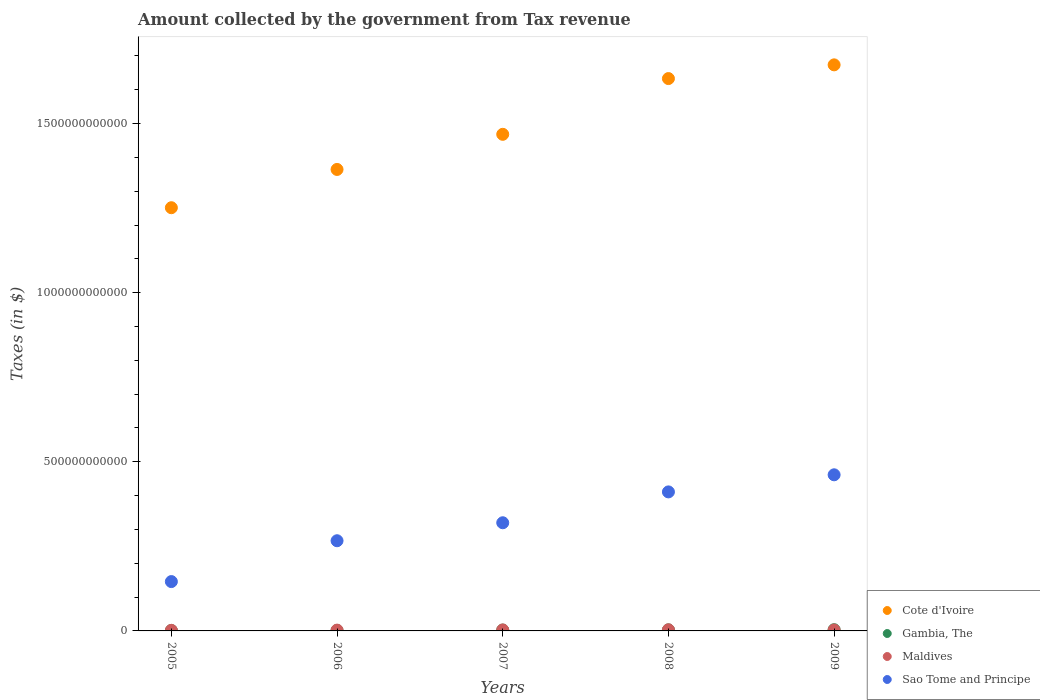What is the amount collected by the government from tax revenue in Gambia, The in 2009?
Keep it short and to the point. 3.63e+09. Across all years, what is the maximum amount collected by the government from tax revenue in Sao Tome and Principe?
Offer a very short reply. 4.62e+11. Across all years, what is the minimum amount collected by the government from tax revenue in Sao Tome and Principe?
Ensure brevity in your answer.  1.46e+11. In which year was the amount collected by the government from tax revenue in Maldives maximum?
Make the answer very short. 2008. In which year was the amount collected by the government from tax revenue in Sao Tome and Principe minimum?
Keep it short and to the point. 2005. What is the total amount collected by the government from tax revenue in Gambia, The in the graph?
Provide a succinct answer. 1.21e+1. What is the difference between the amount collected by the government from tax revenue in Cote d'Ivoire in 2005 and that in 2006?
Your response must be concise. -1.13e+11. What is the difference between the amount collected by the government from tax revenue in Maldives in 2006 and the amount collected by the government from tax revenue in Gambia, The in 2007?
Your response must be concise. -2.19e+08. What is the average amount collected by the government from tax revenue in Gambia, The per year?
Provide a succinct answer. 2.42e+09. In the year 2008, what is the difference between the amount collected by the government from tax revenue in Gambia, The and amount collected by the government from tax revenue in Sao Tome and Principe?
Ensure brevity in your answer.  -4.08e+11. What is the ratio of the amount collected by the government from tax revenue in Maldives in 2006 to that in 2009?
Offer a very short reply. 0.87. What is the difference between the highest and the second highest amount collected by the government from tax revenue in Cote d'Ivoire?
Ensure brevity in your answer.  4.06e+1. What is the difference between the highest and the lowest amount collected by the government from tax revenue in Gambia, The?
Give a very brief answer. 2.34e+09. Is the amount collected by the government from tax revenue in Sao Tome and Principe strictly greater than the amount collected by the government from tax revenue in Cote d'Ivoire over the years?
Your answer should be very brief. No. Is the amount collected by the government from tax revenue in Cote d'Ivoire strictly less than the amount collected by the government from tax revenue in Maldives over the years?
Your response must be concise. No. What is the difference between two consecutive major ticks on the Y-axis?
Keep it short and to the point. 5.00e+11. Does the graph contain any zero values?
Make the answer very short. No. Does the graph contain grids?
Your answer should be very brief. No. Where does the legend appear in the graph?
Ensure brevity in your answer.  Bottom right. How many legend labels are there?
Make the answer very short. 4. What is the title of the graph?
Make the answer very short. Amount collected by the government from Tax revenue. Does "Latvia" appear as one of the legend labels in the graph?
Provide a short and direct response. No. What is the label or title of the Y-axis?
Your answer should be very brief. Taxes (in $). What is the Taxes (in $) of Cote d'Ivoire in 2005?
Make the answer very short. 1.25e+12. What is the Taxes (in $) of Gambia, The in 2005?
Provide a short and direct response. 1.29e+09. What is the Taxes (in $) of Maldives in 2005?
Your answer should be very brief. 1.72e+09. What is the Taxes (in $) of Sao Tome and Principe in 2005?
Keep it short and to the point. 1.46e+11. What is the Taxes (in $) of Cote d'Ivoire in 2006?
Your response must be concise. 1.36e+12. What is the Taxes (in $) in Gambia, The in 2006?
Provide a succinct answer. 1.47e+09. What is the Taxes (in $) of Maldives in 2006?
Provide a succinct answer. 2.37e+09. What is the Taxes (in $) in Sao Tome and Principe in 2006?
Your answer should be very brief. 2.67e+11. What is the Taxes (in $) of Cote d'Ivoire in 2007?
Offer a terse response. 1.47e+12. What is the Taxes (in $) of Gambia, The in 2007?
Offer a terse response. 2.59e+09. What is the Taxes (in $) of Maldives in 2007?
Make the answer very short. 2.91e+09. What is the Taxes (in $) in Sao Tome and Principe in 2007?
Ensure brevity in your answer.  3.20e+11. What is the Taxes (in $) in Cote d'Ivoire in 2008?
Your answer should be compact. 1.63e+12. What is the Taxes (in $) of Gambia, The in 2008?
Your answer should be compact. 3.15e+09. What is the Taxes (in $) in Maldives in 2008?
Offer a terse response. 3.37e+09. What is the Taxes (in $) in Sao Tome and Principe in 2008?
Ensure brevity in your answer.  4.11e+11. What is the Taxes (in $) of Cote d'Ivoire in 2009?
Offer a very short reply. 1.67e+12. What is the Taxes (in $) of Gambia, The in 2009?
Make the answer very short. 3.63e+09. What is the Taxes (in $) of Maldives in 2009?
Provide a succinct answer. 2.73e+09. What is the Taxes (in $) of Sao Tome and Principe in 2009?
Make the answer very short. 4.62e+11. Across all years, what is the maximum Taxes (in $) in Cote d'Ivoire?
Your answer should be compact. 1.67e+12. Across all years, what is the maximum Taxes (in $) of Gambia, The?
Your answer should be very brief. 3.63e+09. Across all years, what is the maximum Taxes (in $) in Maldives?
Offer a very short reply. 3.37e+09. Across all years, what is the maximum Taxes (in $) in Sao Tome and Principe?
Make the answer very short. 4.62e+11. Across all years, what is the minimum Taxes (in $) in Cote d'Ivoire?
Your response must be concise. 1.25e+12. Across all years, what is the minimum Taxes (in $) of Gambia, The?
Provide a short and direct response. 1.29e+09. Across all years, what is the minimum Taxes (in $) in Maldives?
Give a very brief answer. 1.72e+09. Across all years, what is the minimum Taxes (in $) of Sao Tome and Principe?
Offer a terse response. 1.46e+11. What is the total Taxes (in $) in Cote d'Ivoire in the graph?
Your answer should be compact. 7.39e+12. What is the total Taxes (in $) of Gambia, The in the graph?
Give a very brief answer. 1.21e+1. What is the total Taxes (in $) in Maldives in the graph?
Offer a terse response. 1.31e+1. What is the total Taxes (in $) in Sao Tome and Principe in the graph?
Keep it short and to the point. 1.60e+12. What is the difference between the Taxes (in $) in Cote d'Ivoire in 2005 and that in 2006?
Make the answer very short. -1.13e+11. What is the difference between the Taxes (in $) in Gambia, The in 2005 and that in 2006?
Ensure brevity in your answer.  -1.80e+08. What is the difference between the Taxes (in $) of Maldives in 2005 and that in 2006?
Offer a terse response. -6.48e+08. What is the difference between the Taxes (in $) of Sao Tome and Principe in 2005 and that in 2006?
Offer a very short reply. -1.21e+11. What is the difference between the Taxes (in $) of Cote d'Ivoire in 2005 and that in 2007?
Offer a terse response. -2.17e+11. What is the difference between the Taxes (in $) in Gambia, The in 2005 and that in 2007?
Your response must be concise. -1.30e+09. What is the difference between the Taxes (in $) of Maldives in 2005 and that in 2007?
Offer a very short reply. -1.18e+09. What is the difference between the Taxes (in $) in Sao Tome and Principe in 2005 and that in 2007?
Your answer should be compact. -1.74e+11. What is the difference between the Taxes (in $) of Cote d'Ivoire in 2005 and that in 2008?
Provide a succinct answer. -3.82e+11. What is the difference between the Taxes (in $) in Gambia, The in 2005 and that in 2008?
Offer a very short reply. -1.86e+09. What is the difference between the Taxes (in $) in Maldives in 2005 and that in 2008?
Provide a succinct answer. -1.64e+09. What is the difference between the Taxes (in $) of Sao Tome and Principe in 2005 and that in 2008?
Your response must be concise. -2.65e+11. What is the difference between the Taxes (in $) of Cote d'Ivoire in 2005 and that in 2009?
Your answer should be very brief. -4.22e+11. What is the difference between the Taxes (in $) of Gambia, The in 2005 and that in 2009?
Your answer should be very brief. -2.34e+09. What is the difference between the Taxes (in $) of Maldives in 2005 and that in 2009?
Provide a short and direct response. -1.01e+09. What is the difference between the Taxes (in $) of Sao Tome and Principe in 2005 and that in 2009?
Your answer should be compact. -3.16e+11. What is the difference between the Taxes (in $) of Cote d'Ivoire in 2006 and that in 2007?
Provide a short and direct response. -1.04e+11. What is the difference between the Taxes (in $) in Gambia, The in 2006 and that in 2007?
Provide a succinct answer. -1.12e+09. What is the difference between the Taxes (in $) in Maldives in 2006 and that in 2007?
Your answer should be very brief. -5.35e+08. What is the difference between the Taxes (in $) in Sao Tome and Principe in 2006 and that in 2007?
Provide a short and direct response. -5.32e+1. What is the difference between the Taxes (in $) of Cote d'Ivoire in 2006 and that in 2008?
Offer a very short reply. -2.69e+11. What is the difference between the Taxes (in $) in Gambia, The in 2006 and that in 2008?
Offer a terse response. -1.68e+09. What is the difference between the Taxes (in $) in Maldives in 2006 and that in 2008?
Offer a terse response. -9.96e+08. What is the difference between the Taxes (in $) of Sao Tome and Principe in 2006 and that in 2008?
Provide a short and direct response. -1.44e+11. What is the difference between the Taxes (in $) of Cote d'Ivoire in 2006 and that in 2009?
Provide a succinct answer. -3.09e+11. What is the difference between the Taxes (in $) in Gambia, The in 2006 and that in 2009?
Your answer should be compact. -2.16e+09. What is the difference between the Taxes (in $) of Maldives in 2006 and that in 2009?
Provide a succinct answer. -3.62e+08. What is the difference between the Taxes (in $) in Sao Tome and Principe in 2006 and that in 2009?
Ensure brevity in your answer.  -1.95e+11. What is the difference between the Taxes (in $) in Cote d'Ivoire in 2007 and that in 2008?
Your answer should be compact. -1.65e+11. What is the difference between the Taxes (in $) of Gambia, The in 2007 and that in 2008?
Offer a very short reply. -5.57e+08. What is the difference between the Taxes (in $) in Maldives in 2007 and that in 2008?
Make the answer very short. -4.62e+08. What is the difference between the Taxes (in $) of Sao Tome and Principe in 2007 and that in 2008?
Make the answer very short. -9.12e+1. What is the difference between the Taxes (in $) in Cote d'Ivoire in 2007 and that in 2009?
Your answer should be very brief. -2.05e+11. What is the difference between the Taxes (in $) in Gambia, The in 2007 and that in 2009?
Keep it short and to the point. -1.04e+09. What is the difference between the Taxes (in $) of Maldives in 2007 and that in 2009?
Make the answer very short. 1.73e+08. What is the difference between the Taxes (in $) in Sao Tome and Principe in 2007 and that in 2009?
Your answer should be very brief. -1.42e+11. What is the difference between the Taxes (in $) in Cote d'Ivoire in 2008 and that in 2009?
Your answer should be very brief. -4.06e+1. What is the difference between the Taxes (in $) of Gambia, The in 2008 and that in 2009?
Your answer should be very brief. -4.84e+08. What is the difference between the Taxes (in $) of Maldives in 2008 and that in 2009?
Your response must be concise. 6.35e+08. What is the difference between the Taxes (in $) of Sao Tome and Principe in 2008 and that in 2009?
Your response must be concise. -5.06e+1. What is the difference between the Taxes (in $) of Cote d'Ivoire in 2005 and the Taxes (in $) of Gambia, The in 2006?
Provide a short and direct response. 1.25e+12. What is the difference between the Taxes (in $) in Cote d'Ivoire in 2005 and the Taxes (in $) in Maldives in 2006?
Give a very brief answer. 1.25e+12. What is the difference between the Taxes (in $) of Cote d'Ivoire in 2005 and the Taxes (in $) of Sao Tome and Principe in 2006?
Your answer should be very brief. 9.85e+11. What is the difference between the Taxes (in $) of Gambia, The in 2005 and the Taxes (in $) of Maldives in 2006?
Your answer should be compact. -1.08e+09. What is the difference between the Taxes (in $) of Gambia, The in 2005 and the Taxes (in $) of Sao Tome and Principe in 2006?
Make the answer very short. -2.65e+11. What is the difference between the Taxes (in $) of Maldives in 2005 and the Taxes (in $) of Sao Tome and Principe in 2006?
Offer a terse response. -2.65e+11. What is the difference between the Taxes (in $) in Cote d'Ivoire in 2005 and the Taxes (in $) in Gambia, The in 2007?
Give a very brief answer. 1.25e+12. What is the difference between the Taxes (in $) in Cote d'Ivoire in 2005 and the Taxes (in $) in Maldives in 2007?
Your answer should be compact. 1.25e+12. What is the difference between the Taxes (in $) in Cote d'Ivoire in 2005 and the Taxes (in $) in Sao Tome and Principe in 2007?
Ensure brevity in your answer.  9.31e+11. What is the difference between the Taxes (in $) of Gambia, The in 2005 and the Taxes (in $) of Maldives in 2007?
Offer a terse response. -1.62e+09. What is the difference between the Taxes (in $) in Gambia, The in 2005 and the Taxes (in $) in Sao Tome and Principe in 2007?
Keep it short and to the point. -3.18e+11. What is the difference between the Taxes (in $) in Maldives in 2005 and the Taxes (in $) in Sao Tome and Principe in 2007?
Keep it short and to the point. -3.18e+11. What is the difference between the Taxes (in $) of Cote d'Ivoire in 2005 and the Taxes (in $) of Gambia, The in 2008?
Provide a succinct answer. 1.25e+12. What is the difference between the Taxes (in $) in Cote d'Ivoire in 2005 and the Taxes (in $) in Maldives in 2008?
Your answer should be very brief. 1.25e+12. What is the difference between the Taxes (in $) in Cote d'Ivoire in 2005 and the Taxes (in $) in Sao Tome and Principe in 2008?
Make the answer very short. 8.40e+11. What is the difference between the Taxes (in $) in Gambia, The in 2005 and the Taxes (in $) in Maldives in 2008?
Provide a short and direct response. -2.08e+09. What is the difference between the Taxes (in $) in Gambia, The in 2005 and the Taxes (in $) in Sao Tome and Principe in 2008?
Your response must be concise. -4.10e+11. What is the difference between the Taxes (in $) of Maldives in 2005 and the Taxes (in $) of Sao Tome and Principe in 2008?
Keep it short and to the point. -4.09e+11. What is the difference between the Taxes (in $) in Cote d'Ivoire in 2005 and the Taxes (in $) in Gambia, The in 2009?
Your answer should be compact. 1.25e+12. What is the difference between the Taxes (in $) of Cote d'Ivoire in 2005 and the Taxes (in $) of Maldives in 2009?
Your answer should be very brief. 1.25e+12. What is the difference between the Taxes (in $) in Cote d'Ivoire in 2005 and the Taxes (in $) in Sao Tome and Principe in 2009?
Keep it short and to the point. 7.90e+11. What is the difference between the Taxes (in $) in Gambia, The in 2005 and the Taxes (in $) in Maldives in 2009?
Offer a very short reply. -1.45e+09. What is the difference between the Taxes (in $) of Gambia, The in 2005 and the Taxes (in $) of Sao Tome and Principe in 2009?
Your response must be concise. -4.60e+11. What is the difference between the Taxes (in $) in Maldives in 2005 and the Taxes (in $) in Sao Tome and Principe in 2009?
Keep it short and to the point. -4.60e+11. What is the difference between the Taxes (in $) of Cote d'Ivoire in 2006 and the Taxes (in $) of Gambia, The in 2007?
Your answer should be compact. 1.36e+12. What is the difference between the Taxes (in $) of Cote d'Ivoire in 2006 and the Taxes (in $) of Maldives in 2007?
Provide a short and direct response. 1.36e+12. What is the difference between the Taxes (in $) of Cote d'Ivoire in 2006 and the Taxes (in $) of Sao Tome and Principe in 2007?
Offer a terse response. 1.04e+12. What is the difference between the Taxes (in $) in Gambia, The in 2006 and the Taxes (in $) in Maldives in 2007?
Give a very brief answer. -1.44e+09. What is the difference between the Taxes (in $) of Gambia, The in 2006 and the Taxes (in $) of Sao Tome and Principe in 2007?
Offer a very short reply. -3.18e+11. What is the difference between the Taxes (in $) in Maldives in 2006 and the Taxes (in $) in Sao Tome and Principe in 2007?
Your response must be concise. -3.17e+11. What is the difference between the Taxes (in $) in Cote d'Ivoire in 2006 and the Taxes (in $) in Gambia, The in 2008?
Make the answer very short. 1.36e+12. What is the difference between the Taxes (in $) of Cote d'Ivoire in 2006 and the Taxes (in $) of Maldives in 2008?
Provide a short and direct response. 1.36e+12. What is the difference between the Taxes (in $) of Cote d'Ivoire in 2006 and the Taxes (in $) of Sao Tome and Principe in 2008?
Provide a succinct answer. 9.53e+11. What is the difference between the Taxes (in $) of Gambia, The in 2006 and the Taxes (in $) of Maldives in 2008?
Offer a very short reply. -1.90e+09. What is the difference between the Taxes (in $) in Gambia, The in 2006 and the Taxes (in $) in Sao Tome and Principe in 2008?
Give a very brief answer. -4.10e+11. What is the difference between the Taxes (in $) of Maldives in 2006 and the Taxes (in $) of Sao Tome and Principe in 2008?
Give a very brief answer. -4.09e+11. What is the difference between the Taxes (in $) of Cote d'Ivoire in 2006 and the Taxes (in $) of Gambia, The in 2009?
Provide a succinct answer. 1.36e+12. What is the difference between the Taxes (in $) of Cote d'Ivoire in 2006 and the Taxes (in $) of Maldives in 2009?
Your answer should be very brief. 1.36e+12. What is the difference between the Taxes (in $) of Cote d'Ivoire in 2006 and the Taxes (in $) of Sao Tome and Principe in 2009?
Your answer should be compact. 9.03e+11. What is the difference between the Taxes (in $) in Gambia, The in 2006 and the Taxes (in $) in Maldives in 2009?
Ensure brevity in your answer.  -1.27e+09. What is the difference between the Taxes (in $) of Gambia, The in 2006 and the Taxes (in $) of Sao Tome and Principe in 2009?
Offer a terse response. -4.60e+11. What is the difference between the Taxes (in $) of Maldives in 2006 and the Taxes (in $) of Sao Tome and Principe in 2009?
Ensure brevity in your answer.  -4.59e+11. What is the difference between the Taxes (in $) in Cote d'Ivoire in 2007 and the Taxes (in $) in Gambia, The in 2008?
Your answer should be compact. 1.47e+12. What is the difference between the Taxes (in $) of Cote d'Ivoire in 2007 and the Taxes (in $) of Maldives in 2008?
Your answer should be compact. 1.46e+12. What is the difference between the Taxes (in $) in Cote d'Ivoire in 2007 and the Taxes (in $) in Sao Tome and Principe in 2008?
Keep it short and to the point. 1.06e+12. What is the difference between the Taxes (in $) of Gambia, The in 2007 and the Taxes (in $) of Maldives in 2008?
Keep it short and to the point. -7.78e+08. What is the difference between the Taxes (in $) in Gambia, The in 2007 and the Taxes (in $) in Sao Tome and Principe in 2008?
Offer a terse response. -4.08e+11. What is the difference between the Taxes (in $) of Maldives in 2007 and the Taxes (in $) of Sao Tome and Principe in 2008?
Offer a very short reply. -4.08e+11. What is the difference between the Taxes (in $) of Cote d'Ivoire in 2007 and the Taxes (in $) of Gambia, The in 2009?
Provide a succinct answer. 1.46e+12. What is the difference between the Taxes (in $) in Cote d'Ivoire in 2007 and the Taxes (in $) in Maldives in 2009?
Offer a terse response. 1.47e+12. What is the difference between the Taxes (in $) in Cote d'Ivoire in 2007 and the Taxes (in $) in Sao Tome and Principe in 2009?
Offer a terse response. 1.01e+12. What is the difference between the Taxes (in $) in Gambia, The in 2007 and the Taxes (in $) in Maldives in 2009?
Offer a very short reply. -1.43e+08. What is the difference between the Taxes (in $) of Gambia, The in 2007 and the Taxes (in $) of Sao Tome and Principe in 2009?
Provide a short and direct response. -4.59e+11. What is the difference between the Taxes (in $) in Maldives in 2007 and the Taxes (in $) in Sao Tome and Principe in 2009?
Provide a succinct answer. -4.59e+11. What is the difference between the Taxes (in $) in Cote d'Ivoire in 2008 and the Taxes (in $) in Gambia, The in 2009?
Your answer should be very brief. 1.63e+12. What is the difference between the Taxes (in $) of Cote d'Ivoire in 2008 and the Taxes (in $) of Maldives in 2009?
Give a very brief answer. 1.63e+12. What is the difference between the Taxes (in $) in Cote d'Ivoire in 2008 and the Taxes (in $) in Sao Tome and Principe in 2009?
Make the answer very short. 1.17e+12. What is the difference between the Taxes (in $) of Gambia, The in 2008 and the Taxes (in $) of Maldives in 2009?
Provide a short and direct response. 4.14e+08. What is the difference between the Taxes (in $) in Gambia, The in 2008 and the Taxes (in $) in Sao Tome and Principe in 2009?
Give a very brief answer. -4.58e+11. What is the difference between the Taxes (in $) in Maldives in 2008 and the Taxes (in $) in Sao Tome and Principe in 2009?
Keep it short and to the point. -4.58e+11. What is the average Taxes (in $) in Cote d'Ivoire per year?
Keep it short and to the point. 1.48e+12. What is the average Taxes (in $) in Gambia, The per year?
Give a very brief answer. 2.42e+09. What is the average Taxes (in $) in Maldives per year?
Provide a succinct answer. 2.62e+09. What is the average Taxes (in $) in Sao Tome and Principe per year?
Your answer should be very brief. 3.21e+11. In the year 2005, what is the difference between the Taxes (in $) in Cote d'Ivoire and Taxes (in $) in Gambia, The?
Make the answer very short. 1.25e+12. In the year 2005, what is the difference between the Taxes (in $) in Cote d'Ivoire and Taxes (in $) in Maldives?
Provide a short and direct response. 1.25e+12. In the year 2005, what is the difference between the Taxes (in $) of Cote d'Ivoire and Taxes (in $) of Sao Tome and Principe?
Provide a succinct answer. 1.11e+12. In the year 2005, what is the difference between the Taxes (in $) in Gambia, The and Taxes (in $) in Maldives?
Ensure brevity in your answer.  -4.36e+08. In the year 2005, what is the difference between the Taxes (in $) of Gambia, The and Taxes (in $) of Sao Tome and Principe?
Your answer should be very brief. -1.45e+11. In the year 2005, what is the difference between the Taxes (in $) in Maldives and Taxes (in $) in Sao Tome and Principe?
Provide a succinct answer. -1.44e+11. In the year 2006, what is the difference between the Taxes (in $) of Cote d'Ivoire and Taxes (in $) of Gambia, The?
Offer a very short reply. 1.36e+12. In the year 2006, what is the difference between the Taxes (in $) in Cote d'Ivoire and Taxes (in $) in Maldives?
Your response must be concise. 1.36e+12. In the year 2006, what is the difference between the Taxes (in $) of Cote d'Ivoire and Taxes (in $) of Sao Tome and Principe?
Ensure brevity in your answer.  1.10e+12. In the year 2006, what is the difference between the Taxes (in $) in Gambia, The and Taxes (in $) in Maldives?
Ensure brevity in your answer.  -9.04e+08. In the year 2006, what is the difference between the Taxes (in $) of Gambia, The and Taxes (in $) of Sao Tome and Principe?
Provide a succinct answer. -2.65e+11. In the year 2006, what is the difference between the Taxes (in $) of Maldives and Taxes (in $) of Sao Tome and Principe?
Ensure brevity in your answer.  -2.64e+11. In the year 2007, what is the difference between the Taxes (in $) in Cote d'Ivoire and Taxes (in $) in Gambia, The?
Provide a short and direct response. 1.47e+12. In the year 2007, what is the difference between the Taxes (in $) in Cote d'Ivoire and Taxes (in $) in Maldives?
Your answer should be very brief. 1.47e+12. In the year 2007, what is the difference between the Taxes (in $) in Cote d'Ivoire and Taxes (in $) in Sao Tome and Principe?
Keep it short and to the point. 1.15e+12. In the year 2007, what is the difference between the Taxes (in $) of Gambia, The and Taxes (in $) of Maldives?
Provide a succinct answer. -3.16e+08. In the year 2007, what is the difference between the Taxes (in $) of Gambia, The and Taxes (in $) of Sao Tome and Principe?
Your answer should be very brief. -3.17e+11. In the year 2007, what is the difference between the Taxes (in $) of Maldives and Taxes (in $) of Sao Tome and Principe?
Provide a succinct answer. -3.17e+11. In the year 2008, what is the difference between the Taxes (in $) in Cote d'Ivoire and Taxes (in $) in Gambia, The?
Keep it short and to the point. 1.63e+12. In the year 2008, what is the difference between the Taxes (in $) in Cote d'Ivoire and Taxes (in $) in Maldives?
Provide a short and direct response. 1.63e+12. In the year 2008, what is the difference between the Taxes (in $) of Cote d'Ivoire and Taxes (in $) of Sao Tome and Principe?
Make the answer very short. 1.22e+12. In the year 2008, what is the difference between the Taxes (in $) in Gambia, The and Taxes (in $) in Maldives?
Provide a succinct answer. -2.21e+08. In the year 2008, what is the difference between the Taxes (in $) of Gambia, The and Taxes (in $) of Sao Tome and Principe?
Ensure brevity in your answer.  -4.08e+11. In the year 2008, what is the difference between the Taxes (in $) in Maldives and Taxes (in $) in Sao Tome and Principe?
Your response must be concise. -4.08e+11. In the year 2009, what is the difference between the Taxes (in $) in Cote d'Ivoire and Taxes (in $) in Gambia, The?
Your answer should be very brief. 1.67e+12. In the year 2009, what is the difference between the Taxes (in $) in Cote d'Ivoire and Taxes (in $) in Maldives?
Provide a succinct answer. 1.67e+12. In the year 2009, what is the difference between the Taxes (in $) of Cote d'Ivoire and Taxes (in $) of Sao Tome and Principe?
Offer a terse response. 1.21e+12. In the year 2009, what is the difference between the Taxes (in $) of Gambia, The and Taxes (in $) of Maldives?
Offer a very short reply. 8.98e+08. In the year 2009, what is the difference between the Taxes (in $) of Gambia, The and Taxes (in $) of Sao Tome and Principe?
Make the answer very short. -4.58e+11. In the year 2009, what is the difference between the Taxes (in $) of Maldives and Taxes (in $) of Sao Tome and Principe?
Provide a succinct answer. -4.59e+11. What is the ratio of the Taxes (in $) of Cote d'Ivoire in 2005 to that in 2006?
Your answer should be very brief. 0.92. What is the ratio of the Taxes (in $) in Gambia, The in 2005 to that in 2006?
Your answer should be compact. 0.88. What is the ratio of the Taxes (in $) in Maldives in 2005 to that in 2006?
Your answer should be compact. 0.73. What is the ratio of the Taxes (in $) in Sao Tome and Principe in 2005 to that in 2006?
Ensure brevity in your answer.  0.55. What is the ratio of the Taxes (in $) of Cote d'Ivoire in 2005 to that in 2007?
Provide a succinct answer. 0.85. What is the ratio of the Taxes (in $) of Gambia, The in 2005 to that in 2007?
Make the answer very short. 0.5. What is the ratio of the Taxes (in $) in Maldives in 2005 to that in 2007?
Ensure brevity in your answer.  0.59. What is the ratio of the Taxes (in $) of Sao Tome and Principe in 2005 to that in 2007?
Your answer should be very brief. 0.46. What is the ratio of the Taxes (in $) in Cote d'Ivoire in 2005 to that in 2008?
Give a very brief answer. 0.77. What is the ratio of the Taxes (in $) in Gambia, The in 2005 to that in 2008?
Make the answer very short. 0.41. What is the ratio of the Taxes (in $) of Maldives in 2005 to that in 2008?
Your answer should be compact. 0.51. What is the ratio of the Taxes (in $) of Sao Tome and Principe in 2005 to that in 2008?
Make the answer very short. 0.35. What is the ratio of the Taxes (in $) of Cote d'Ivoire in 2005 to that in 2009?
Your response must be concise. 0.75. What is the ratio of the Taxes (in $) in Gambia, The in 2005 to that in 2009?
Your response must be concise. 0.35. What is the ratio of the Taxes (in $) in Maldives in 2005 to that in 2009?
Provide a short and direct response. 0.63. What is the ratio of the Taxes (in $) of Sao Tome and Principe in 2005 to that in 2009?
Your answer should be very brief. 0.32. What is the ratio of the Taxes (in $) of Cote d'Ivoire in 2006 to that in 2007?
Offer a terse response. 0.93. What is the ratio of the Taxes (in $) of Gambia, The in 2006 to that in 2007?
Make the answer very short. 0.57. What is the ratio of the Taxes (in $) of Maldives in 2006 to that in 2007?
Your answer should be very brief. 0.82. What is the ratio of the Taxes (in $) of Sao Tome and Principe in 2006 to that in 2007?
Your response must be concise. 0.83. What is the ratio of the Taxes (in $) in Cote d'Ivoire in 2006 to that in 2008?
Offer a very short reply. 0.84. What is the ratio of the Taxes (in $) of Gambia, The in 2006 to that in 2008?
Offer a very short reply. 0.47. What is the ratio of the Taxes (in $) of Maldives in 2006 to that in 2008?
Provide a short and direct response. 0.7. What is the ratio of the Taxes (in $) in Sao Tome and Principe in 2006 to that in 2008?
Your answer should be compact. 0.65. What is the ratio of the Taxes (in $) in Cote d'Ivoire in 2006 to that in 2009?
Ensure brevity in your answer.  0.82. What is the ratio of the Taxes (in $) in Gambia, The in 2006 to that in 2009?
Your answer should be very brief. 0.4. What is the ratio of the Taxes (in $) in Maldives in 2006 to that in 2009?
Provide a succinct answer. 0.87. What is the ratio of the Taxes (in $) in Sao Tome and Principe in 2006 to that in 2009?
Offer a terse response. 0.58. What is the ratio of the Taxes (in $) of Cote d'Ivoire in 2007 to that in 2008?
Your answer should be compact. 0.9. What is the ratio of the Taxes (in $) in Gambia, The in 2007 to that in 2008?
Your answer should be compact. 0.82. What is the ratio of the Taxes (in $) of Maldives in 2007 to that in 2008?
Provide a succinct answer. 0.86. What is the ratio of the Taxes (in $) of Sao Tome and Principe in 2007 to that in 2008?
Your answer should be compact. 0.78. What is the ratio of the Taxes (in $) of Cote d'Ivoire in 2007 to that in 2009?
Make the answer very short. 0.88. What is the ratio of the Taxes (in $) of Gambia, The in 2007 to that in 2009?
Offer a very short reply. 0.71. What is the ratio of the Taxes (in $) in Maldives in 2007 to that in 2009?
Offer a very short reply. 1.06. What is the ratio of the Taxes (in $) in Sao Tome and Principe in 2007 to that in 2009?
Your answer should be compact. 0.69. What is the ratio of the Taxes (in $) of Cote d'Ivoire in 2008 to that in 2009?
Provide a succinct answer. 0.98. What is the ratio of the Taxes (in $) in Gambia, The in 2008 to that in 2009?
Give a very brief answer. 0.87. What is the ratio of the Taxes (in $) in Maldives in 2008 to that in 2009?
Offer a terse response. 1.23. What is the ratio of the Taxes (in $) of Sao Tome and Principe in 2008 to that in 2009?
Offer a terse response. 0.89. What is the difference between the highest and the second highest Taxes (in $) of Cote d'Ivoire?
Provide a succinct answer. 4.06e+1. What is the difference between the highest and the second highest Taxes (in $) in Gambia, The?
Keep it short and to the point. 4.84e+08. What is the difference between the highest and the second highest Taxes (in $) of Maldives?
Your response must be concise. 4.62e+08. What is the difference between the highest and the second highest Taxes (in $) in Sao Tome and Principe?
Offer a very short reply. 5.06e+1. What is the difference between the highest and the lowest Taxes (in $) of Cote d'Ivoire?
Keep it short and to the point. 4.22e+11. What is the difference between the highest and the lowest Taxes (in $) in Gambia, The?
Give a very brief answer. 2.34e+09. What is the difference between the highest and the lowest Taxes (in $) in Maldives?
Offer a very short reply. 1.64e+09. What is the difference between the highest and the lowest Taxes (in $) in Sao Tome and Principe?
Keep it short and to the point. 3.16e+11. 